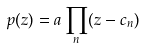<formula> <loc_0><loc_0><loc_500><loc_500>p ( z ) = a \prod _ { n } ( z - c _ { n } )</formula> 